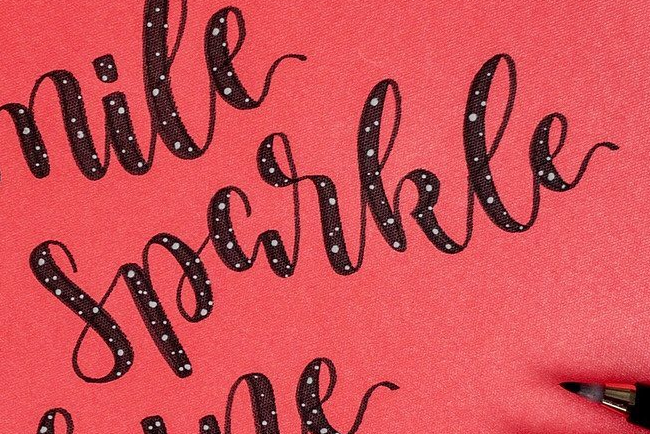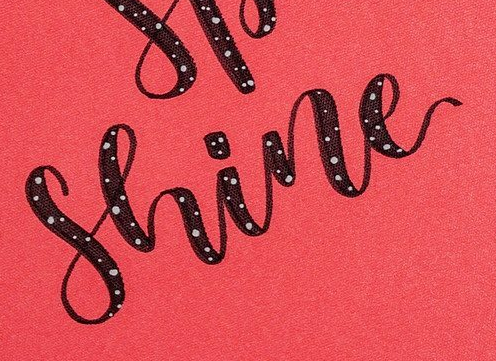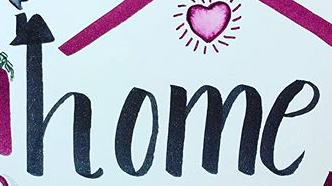Read the text content from these images in order, separated by a semicolon. Sparkle; Shine; home 